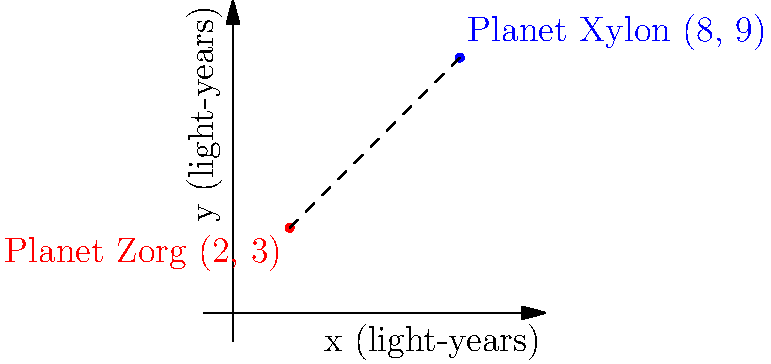In the classic sci-fi series "Galactic Voyagers," the Federation uses a coordinate system to map the galaxy. Planet Zorg is located at (2, 3) and Planet Xylon is at (8, 9) in light-years. Calculate the distance between these two alien worlds using the galactic coordinate system. Round your answer to two decimal places. To find the distance between two points in a coordinate system, we can use the distance formula, which is derived from the Pythagorean theorem:

$$ d = \sqrt{(x_2 - x_1)^2 + (y_2 - y_1)^2} $$

Where $(x_1, y_1)$ is the coordinate of the first point and $(x_2, y_2)$ is the coordinate of the second point.

Let's plug in our values:
- Planet Zorg: $(x_1, y_1) = (2, 3)$
- Planet Xylon: $(x_2, y_2) = (8, 9)$

Now, let's calculate:

$$ d = \sqrt{(8 - 2)^2 + (9 - 3)^2} $$
$$ d = \sqrt{6^2 + 6^2} $$
$$ d = \sqrt{36 + 36} $$
$$ d = \sqrt{72} $$
$$ d \approx 8.4853 $$

Rounding to two decimal places, we get 8.49 light-years.
Answer: 8.49 light-years 